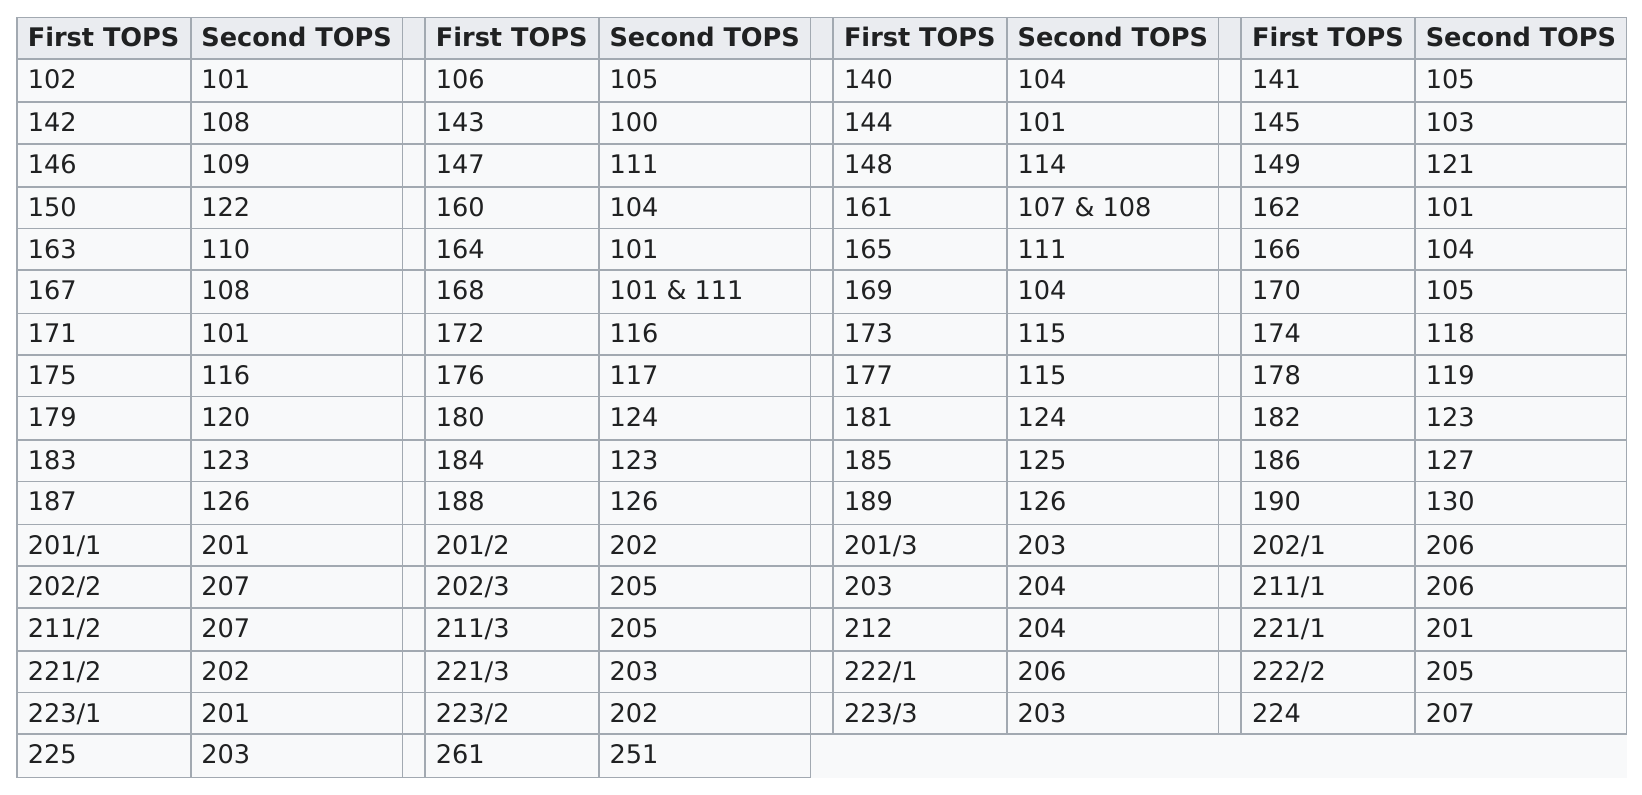Specify some key components in this picture. The largest first-class number is 261. The number of seconds that are listed in the column header is four. Of the seconds that were under 200, 11 were the most prevalent. Out of the tops that have listed two numbers within the same cell, 2 of them have been identified. The largest number listed is 261.. 